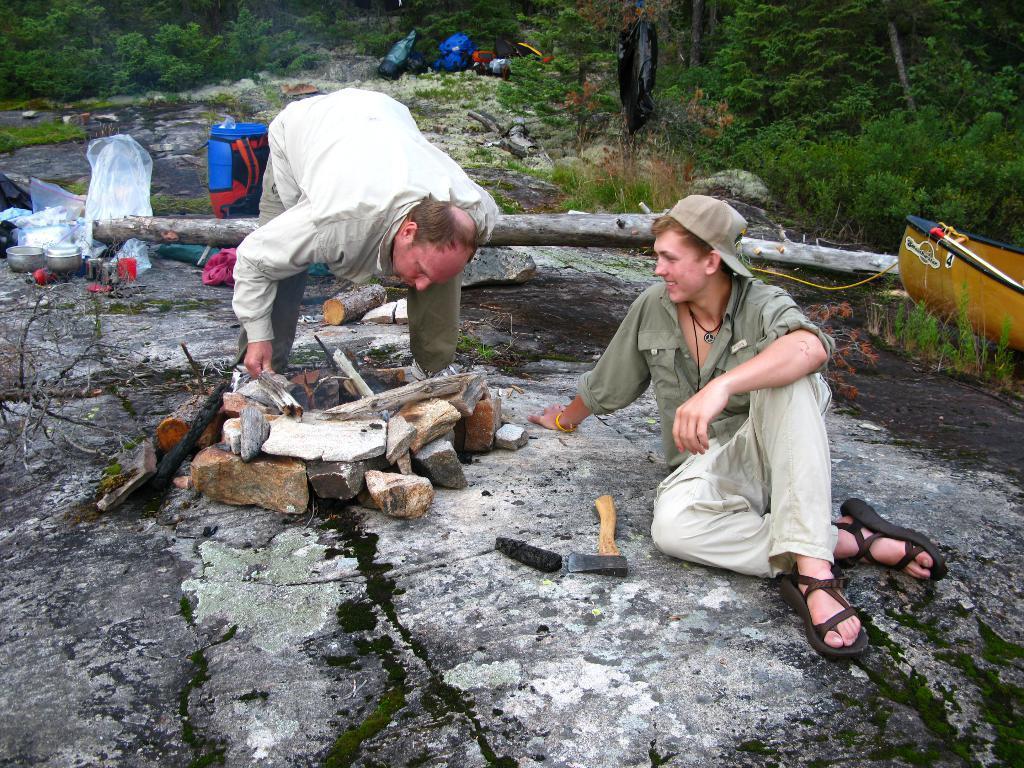In one or two sentences, can you explain what this image depicts? In this picture there is a man who is wearing shirt, trouser and shoes. He is holding the woods. On the right there is a man who is sitting on the ground, beside him I can see the wood boxes. On the left I can see some basket, bowls, jar and other objects. In the back I can see some peoples were standing near to the tent. On the background I can see many trees and stones. 